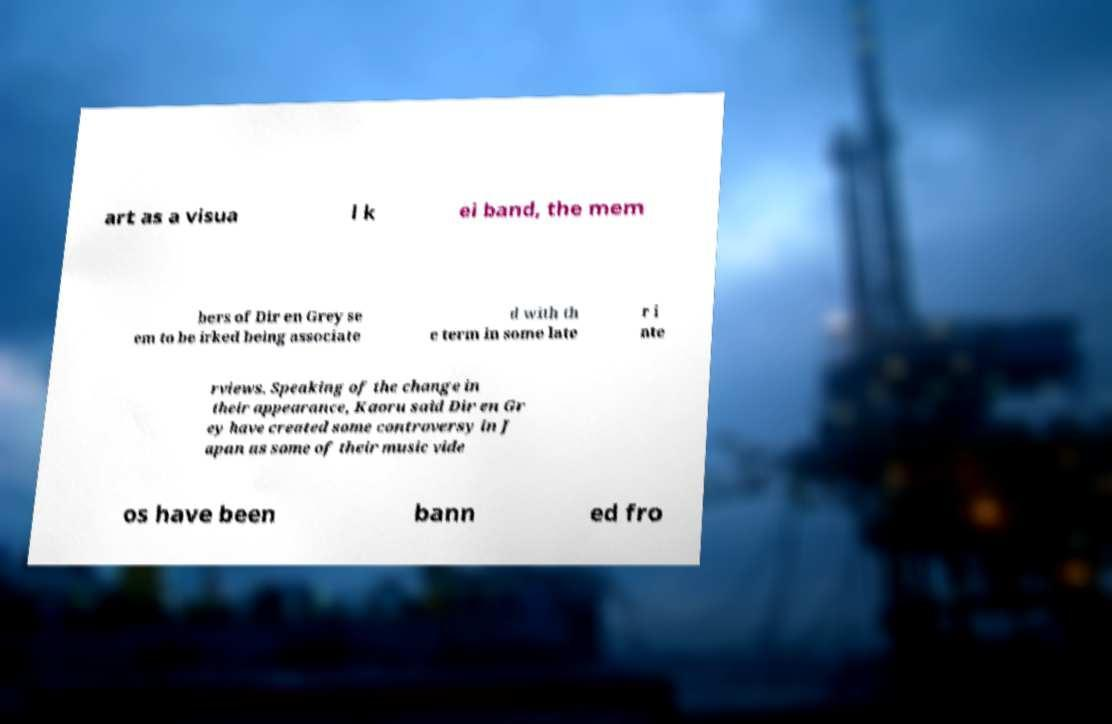Can you read and provide the text displayed in the image?This photo seems to have some interesting text. Can you extract and type it out for me? art as a visua l k ei band, the mem bers of Dir en Grey se em to be irked being associate d with th e term in some late r i nte rviews. Speaking of the change in their appearance, Kaoru said Dir en Gr ey have created some controversy in J apan as some of their music vide os have been bann ed fro 